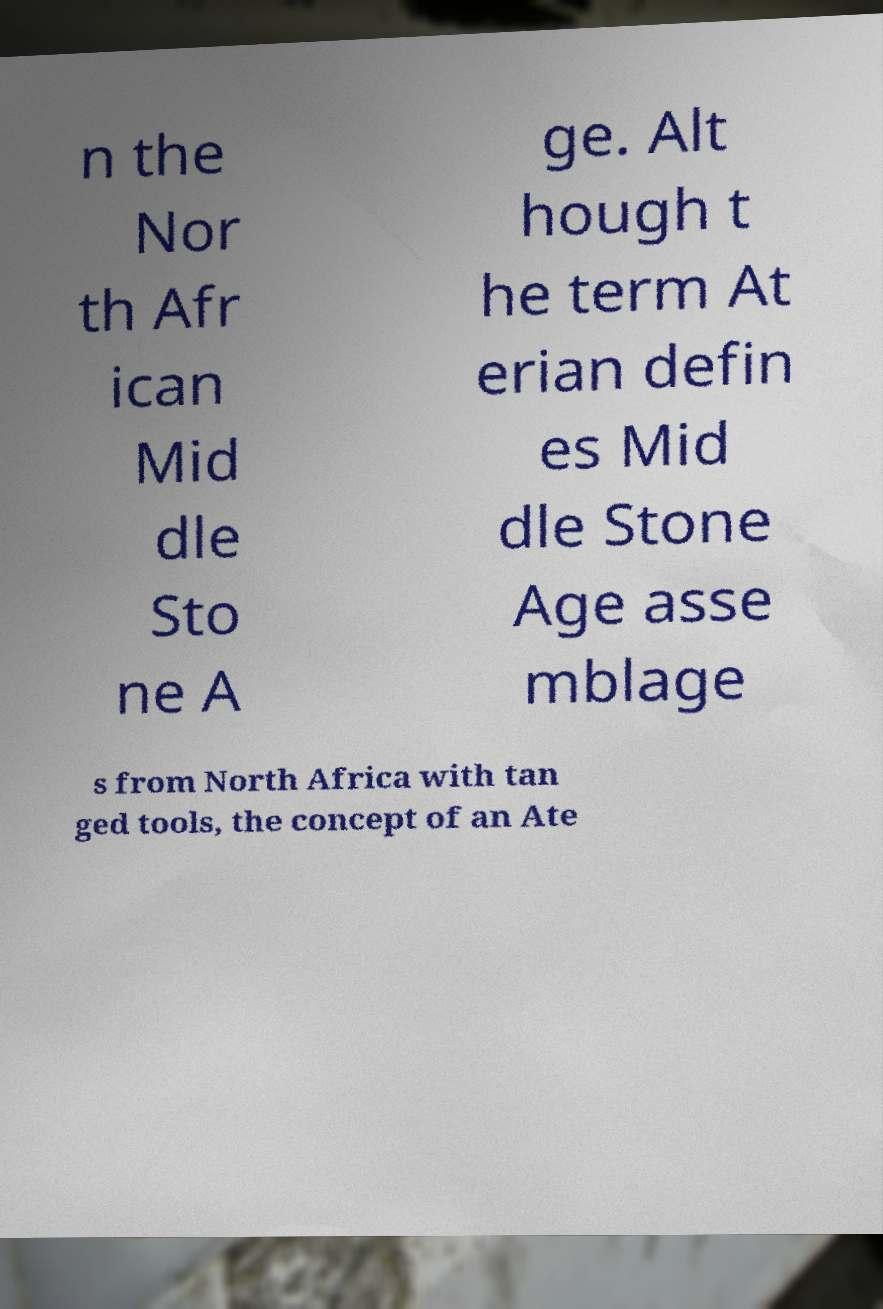There's text embedded in this image that I need extracted. Can you transcribe it verbatim? n the Nor th Afr ican Mid dle Sto ne A ge. Alt hough t he term At erian defin es Mid dle Stone Age asse mblage s from North Africa with tan ged tools, the concept of an Ate 